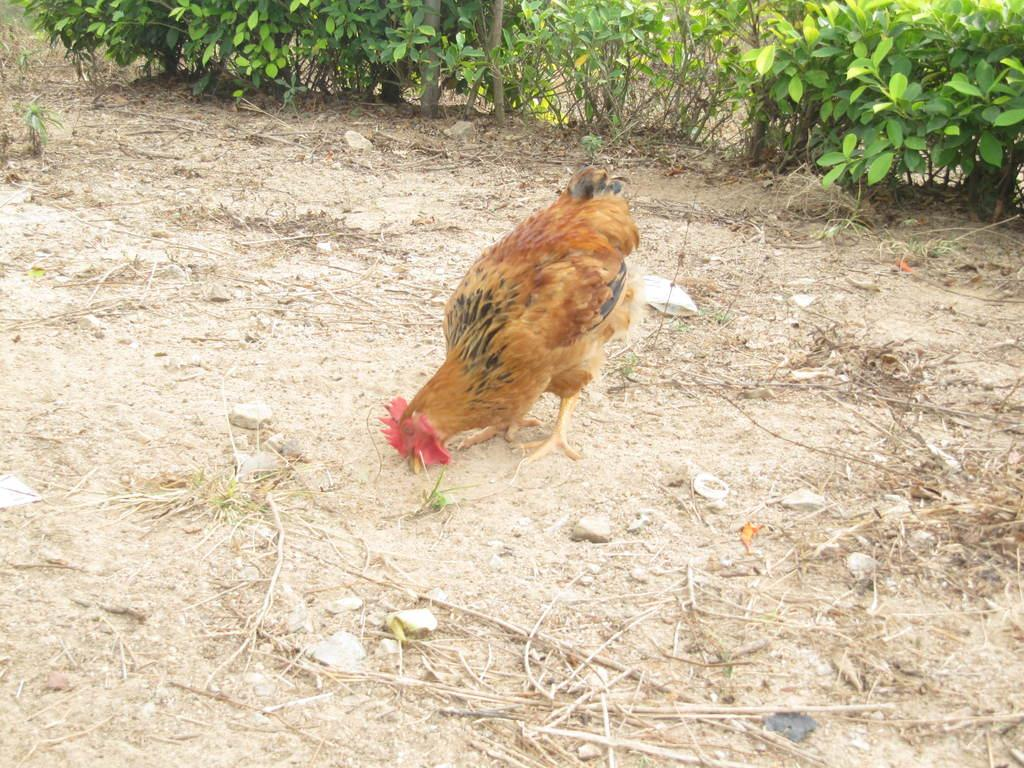What animal is the main subject of the picture? There is a rooster in the picture. What is the rooster doing in the picture? The rooster is eating insects. What can be seen in the background of the picture? There are plants in the background of the picture. What type of objects are on the floor in the picture? There are stones and twigs on the floor in the picture. How does the rooster's dad react to the crowd in the image? There is no crowd or dad present in the image; it features a rooster eating insects with plants, stones, and twigs in the background. 